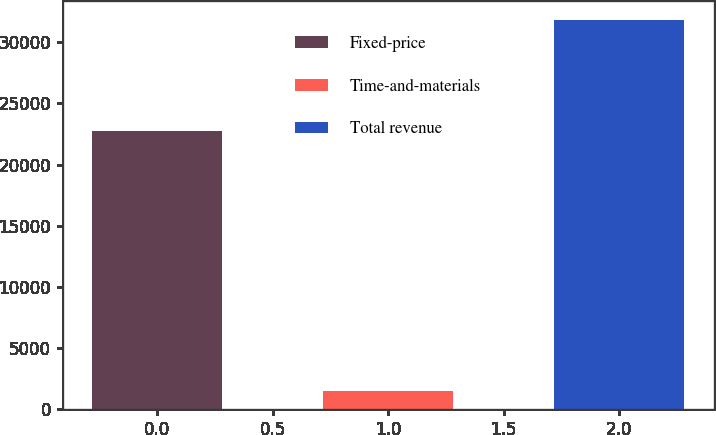Convert chart to OTSL. <chart><loc_0><loc_0><loc_500><loc_500><bar_chart><fcel>Fixed-price<fcel>Time-and-materials<fcel>Total revenue<nl><fcel>22759<fcel>1470<fcel>31781<nl></chart> 